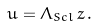Convert formula to latex. <formula><loc_0><loc_0><loc_500><loc_500>u = \Lambda _ { S c l } \, z \, .</formula> 